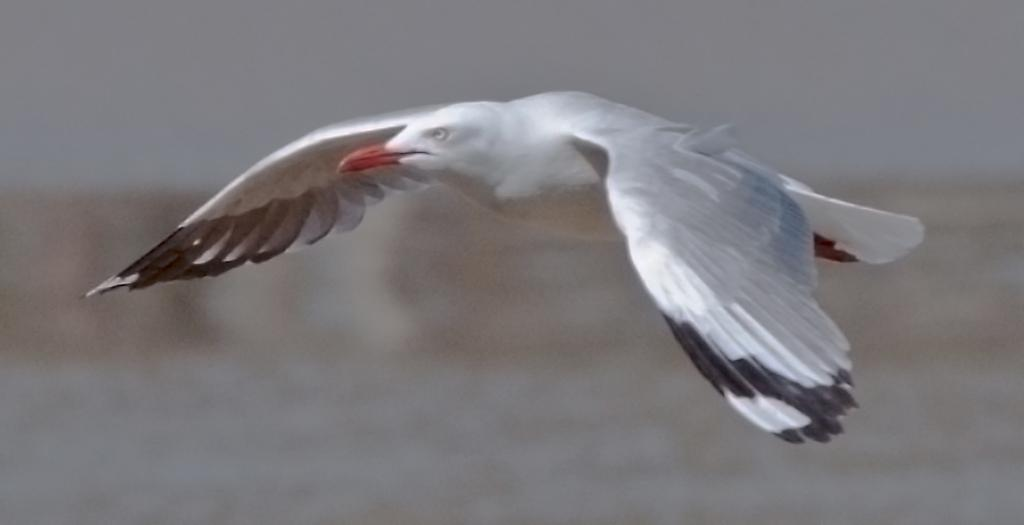What type of animal can be seen in the image? There is a bird in the image. What is the bird doing in the image? The bird is flying. Is there a crook trying to catch the bird in the image? There is no crook present in the image, and therefore no such interaction can be observed. 